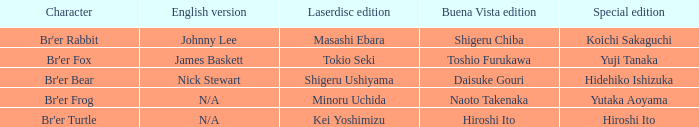What is the distinctive edition for the english version of james baskett? Yuji Tanaka. 